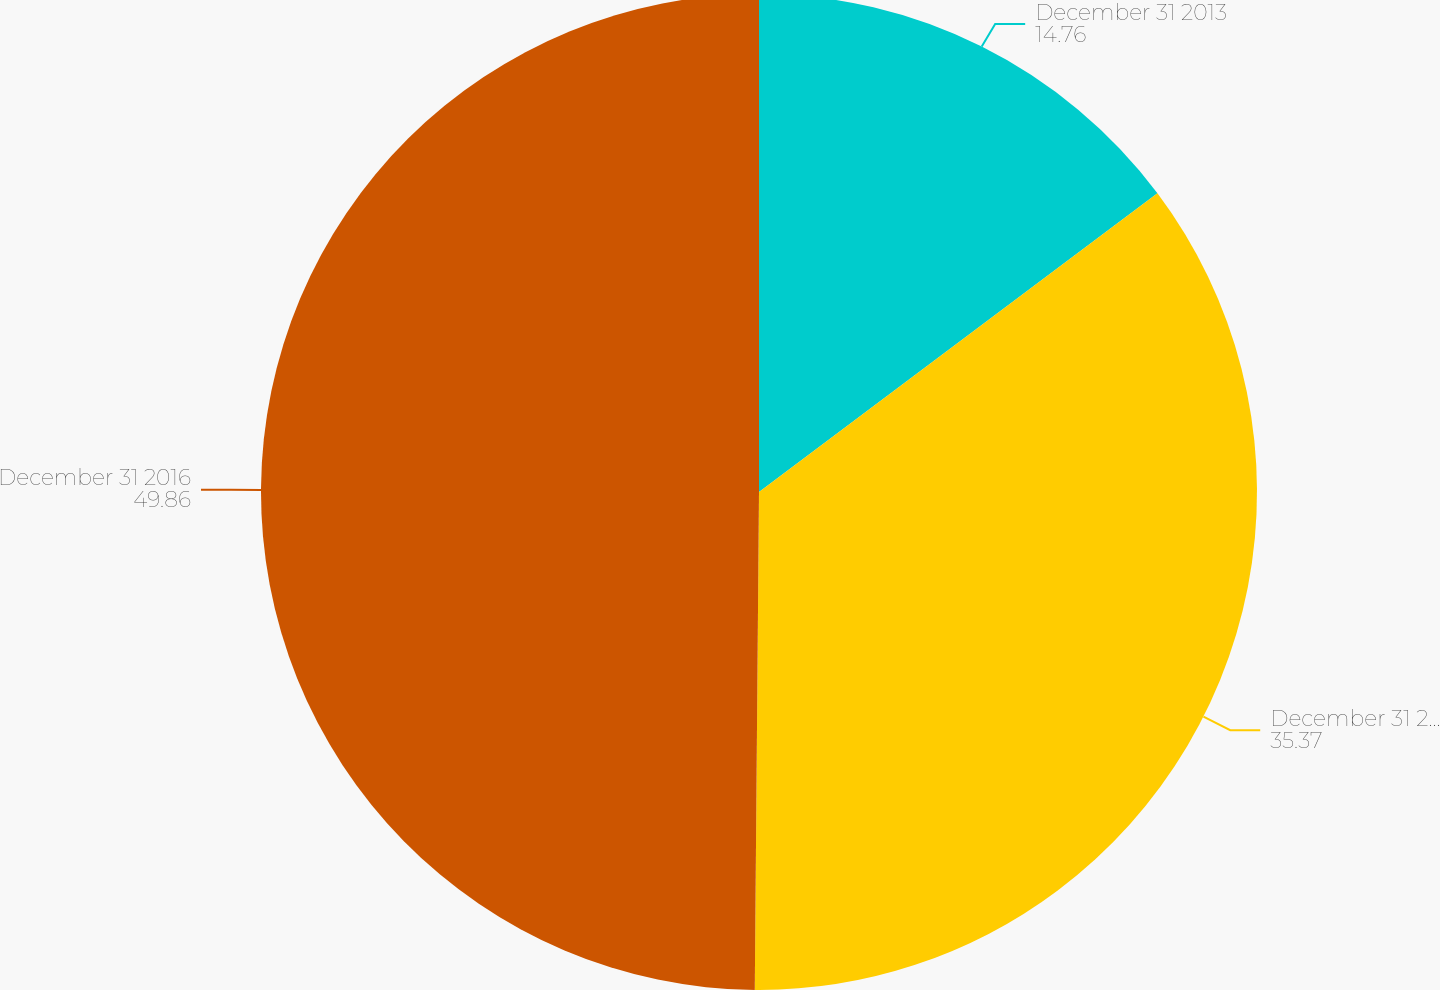Convert chart. <chart><loc_0><loc_0><loc_500><loc_500><pie_chart><fcel>December 31 2013<fcel>December 31 2014<fcel>December 31 2016<nl><fcel>14.76%<fcel>35.37%<fcel>49.86%<nl></chart> 